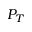Convert formula to latex. <formula><loc_0><loc_0><loc_500><loc_500>P _ { T }</formula> 